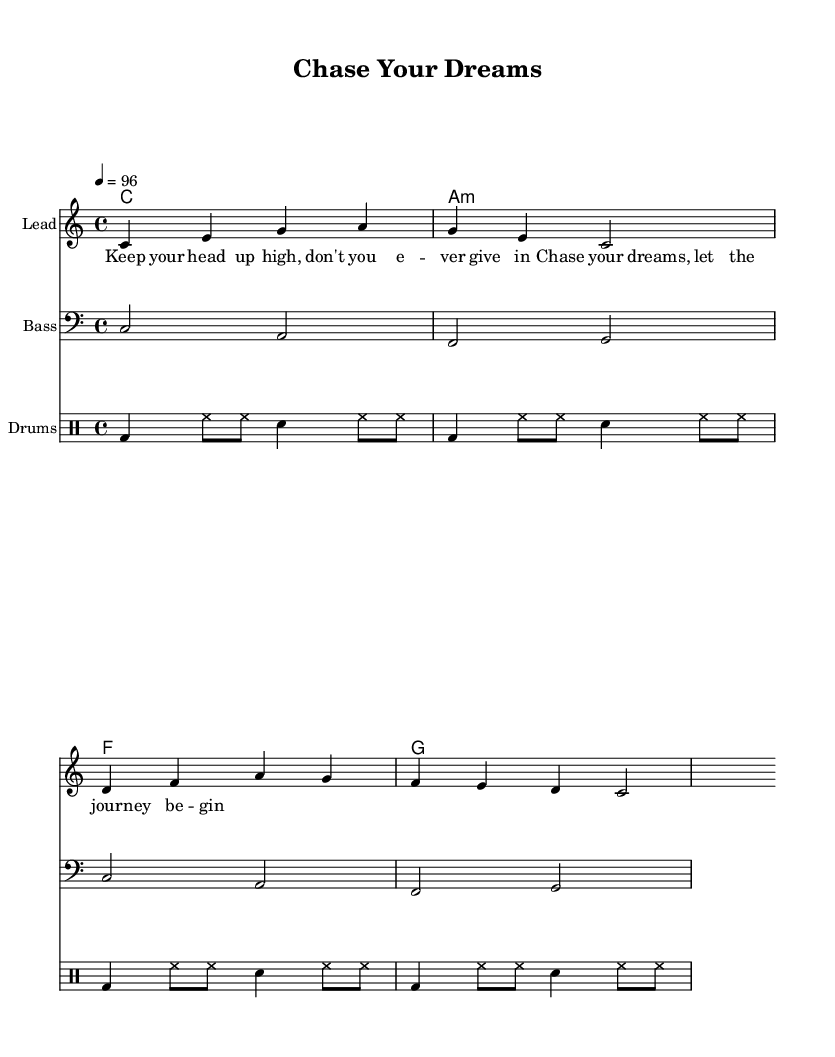What is the key signature of this music? The key signature is C major, which has no sharps or flats indicated in the music.
Answer: C major What is the time signature of this music? The time signature is indicated as 4/4, showing there are four beats in each measure.
Answer: 4/4 What is the tempo marking for this piece? The tempo marking is indicated as 4 = 96, which means there are 96 beats per minute using quarter notes.
Answer: 96 What is the main theme of the lyrics? The lyrics encourage perseverance and belief in oneself while chasing dreams, as emphasized by the phrases used.
Answer: Perseverance How many measures are in the melody section? Counting the measures presented in the melody, there are four measures in total before moving to a new section.
Answer: 4 Which instrument plays the bass line in this score? The bass line is specifically notated with a bass clef, indicating that a bass instrument is responsible for this part.
Answer: Bass What is the rhythmic pattern used for the drums? The drum part alternates between bass drum, hi-hat, and snare with a consistent eighth-note and quarter-note rhythm.
Answer: Alternating 